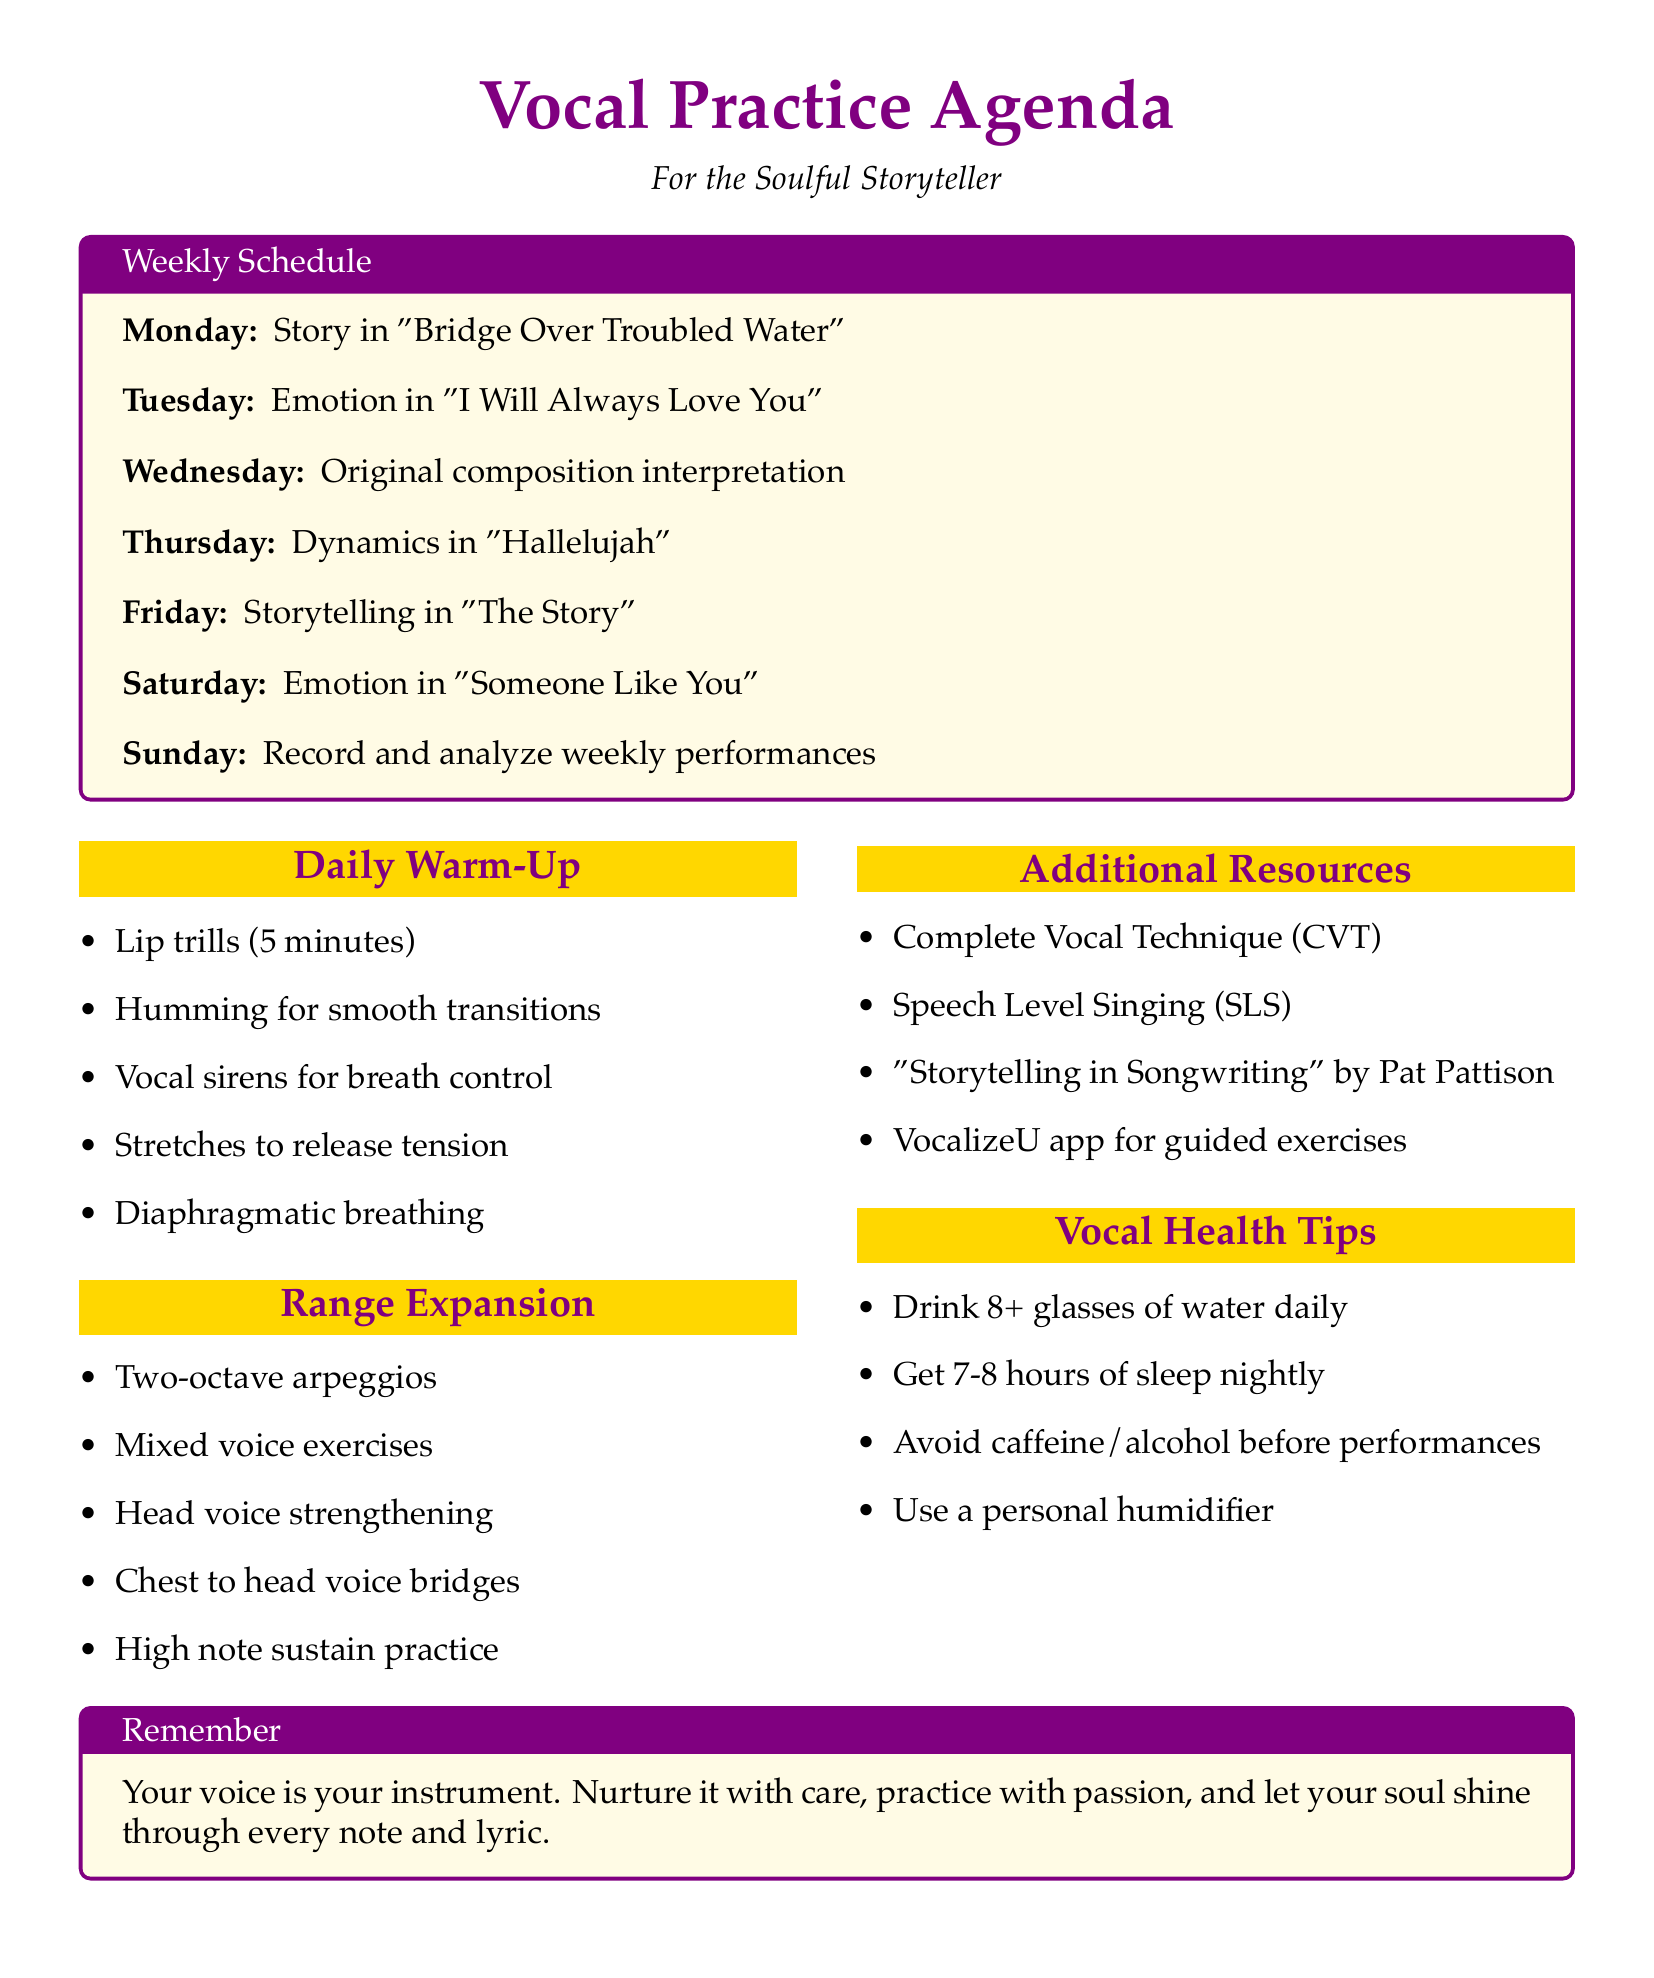What is the practice goal for Monday? The practice goal is to focus on storytelling techniques in "Bridge Over Troubled Water" by Simon & Garfunkel.
Answer: Work on storytelling techniques in "Bridge Over Troubled Water" What warm-up exercise is done on Tuesday? The warm-up exercises include neck and shoulder stretches to release tension.
Answer: Neck and shoulder stretches to release tension Which range expansion exercise is included on Saturday? The range expansion exercises on Saturday include vocal runs and riffs practice.
Answer: Vocal runs and riffs practice How many octaves do the arpeggios span on Monday? The arpeggios spanning two octaves specify how many octaves the exercise covers.
Answer: Two octaves What principles are recommended in the additional resources? The principles of Speech Level Singing (SLS) are included as additional resources.
Answer: Speech Level Singing (SLS) principles 